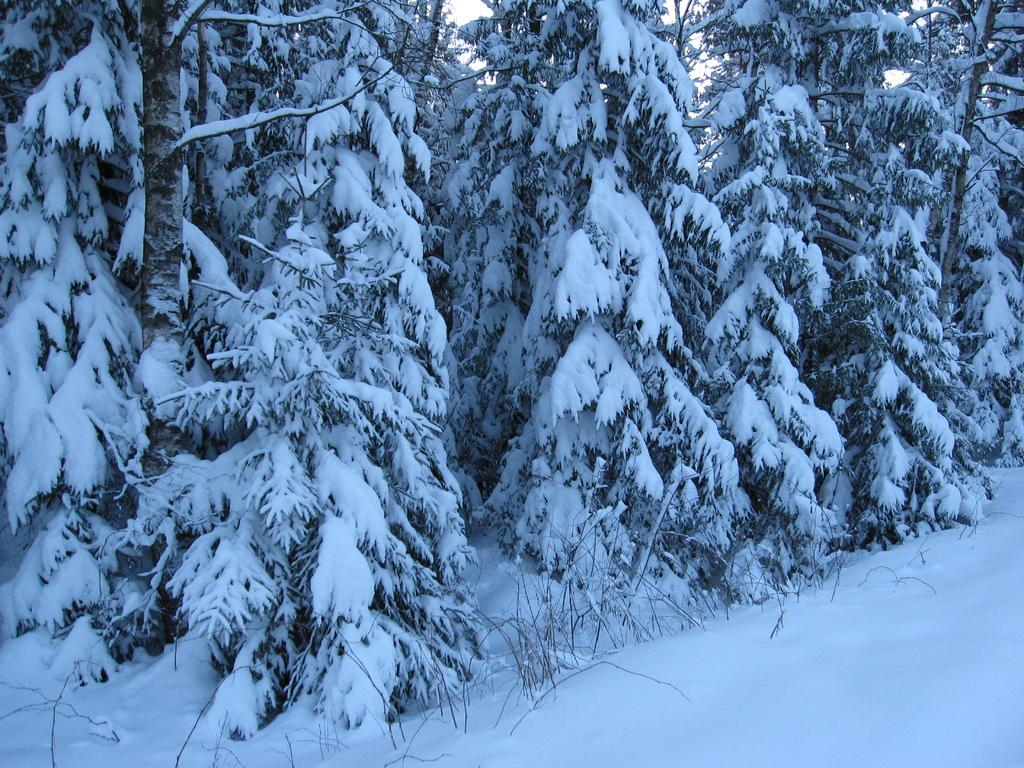What type of weather condition is depicted in the image? There is snow on the land and some trees in the image, indicating a snowy weather condition. What type of vegetation is present in the image? There are trees in the image. What can be seen in the background of the image? The sky is visible in the background of the image. What type of pump is visible in the image? There is no pump present in the image. What type of beef is being served in the image? There is no beef present in the image. 